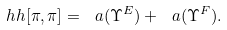<formula> <loc_0><loc_0><loc_500><loc_500>\ h h [ \pi , \pi ] = \ a ( \Upsilon ^ { E } ) + \ a ( \Upsilon ^ { F } ) .</formula> 